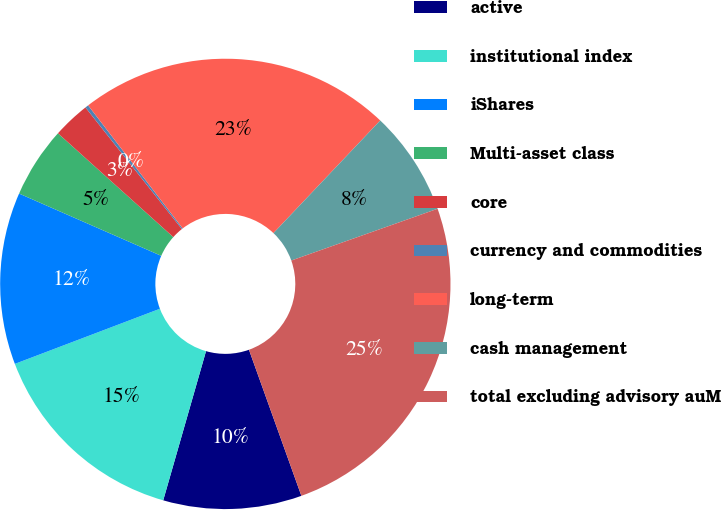<chart> <loc_0><loc_0><loc_500><loc_500><pie_chart><fcel>active<fcel>institutional index<fcel>iShares<fcel>Multi-asset class<fcel>core<fcel>currency and commodities<fcel>long-term<fcel>cash management<fcel>total excluding advisory auM<nl><fcel>9.93%<fcel>14.77%<fcel>12.35%<fcel>5.09%<fcel>2.67%<fcel>0.24%<fcel>22.5%<fcel>7.51%<fcel>24.93%<nl></chart> 